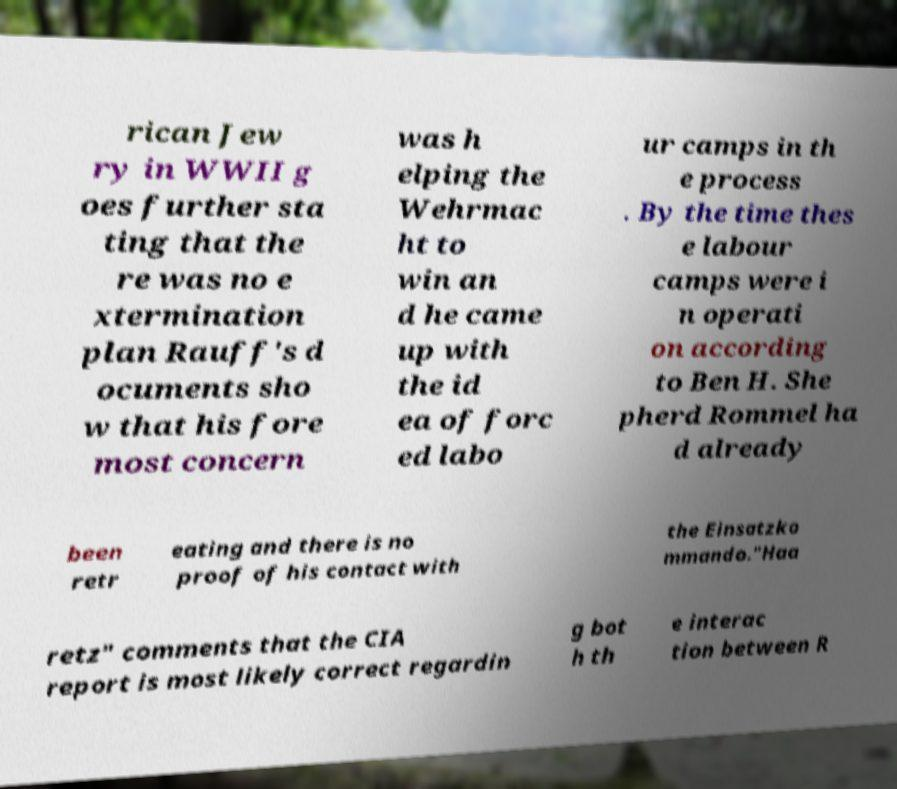Please read and relay the text visible in this image. What does it say? rican Jew ry in WWII g oes further sta ting that the re was no e xtermination plan Rauff's d ocuments sho w that his fore most concern was h elping the Wehrmac ht to win an d he came up with the id ea of forc ed labo ur camps in th e process . By the time thes e labour camps were i n operati on according to Ben H. She pherd Rommel ha d already been retr eating and there is no proof of his contact with the Einsatzko mmando."Haa retz" comments that the CIA report is most likely correct regardin g bot h th e interac tion between R 